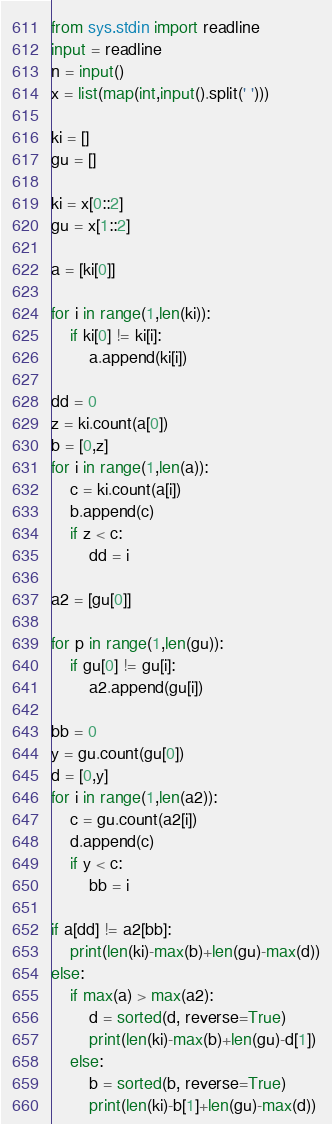Convert code to text. <code><loc_0><loc_0><loc_500><loc_500><_Python_>from sys.stdin import readline
input = readline
n = input()
x = list(map(int,input().split(' ')))

ki = []
gu = []

ki = x[0::2]
gu = x[1::2]

a = [ki[0]]

for i in range(1,len(ki)):
    if ki[0] != ki[i]:
        a.append(ki[i])

dd = 0
z = ki.count(a[0])
b = [0,z]
for i in range(1,len(a)):
    c = ki.count(a[i])
    b.append(c)
    if z < c:
        dd = i

a2 = [gu[0]]

for p in range(1,len(gu)):
    if gu[0] != gu[i]:
        a2.append(gu[i])

bb = 0
y = gu.count(gu[0])
d = [0,y]
for i in range(1,len(a2)):
    c = gu.count(a2[i])
    d.append(c)
    if y < c:
        bb = i

if a[dd] != a2[bb]:
    print(len(ki)-max(b)+len(gu)-max(d))
else:
    if max(a) > max(a2):
        d = sorted(d, reverse=True)
        print(len(ki)-max(b)+len(gu)-d[1])
    else:
        b = sorted(b, reverse=True)
        print(len(ki)-b[1]+len(gu)-max(d))
</code> 